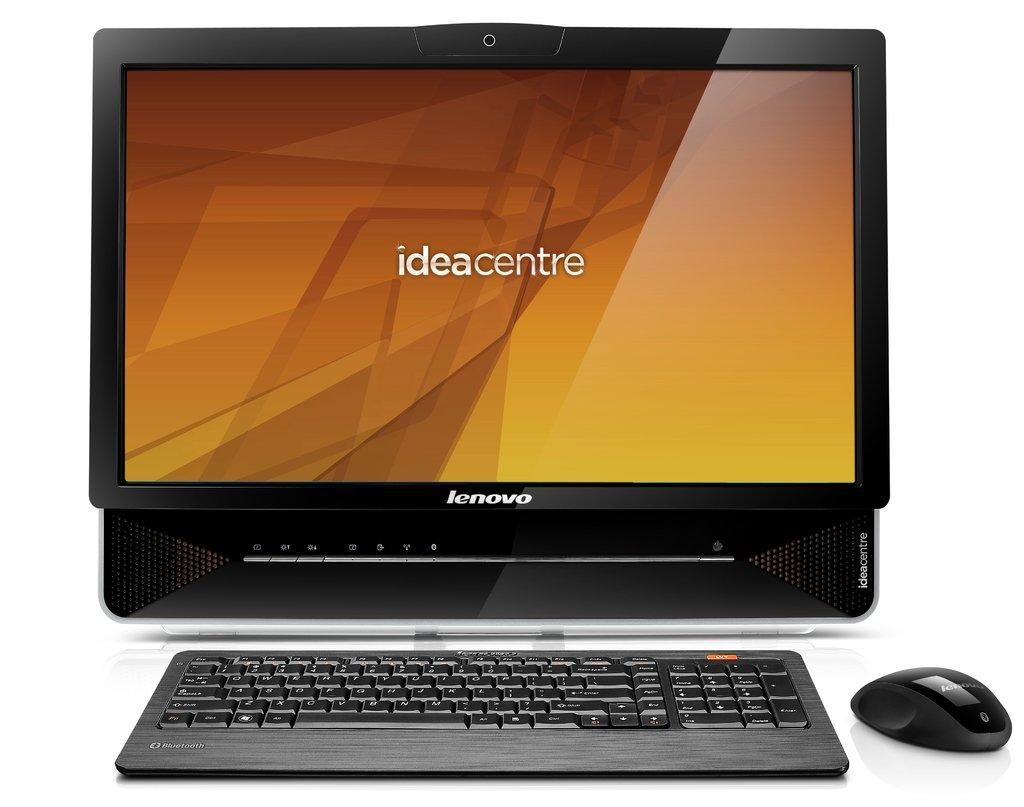<image>
Write a terse but informative summary of the picture. An opened black laptop on a table with the screen showing different shades of yellow and gold and also says ideacentre across the screen. 